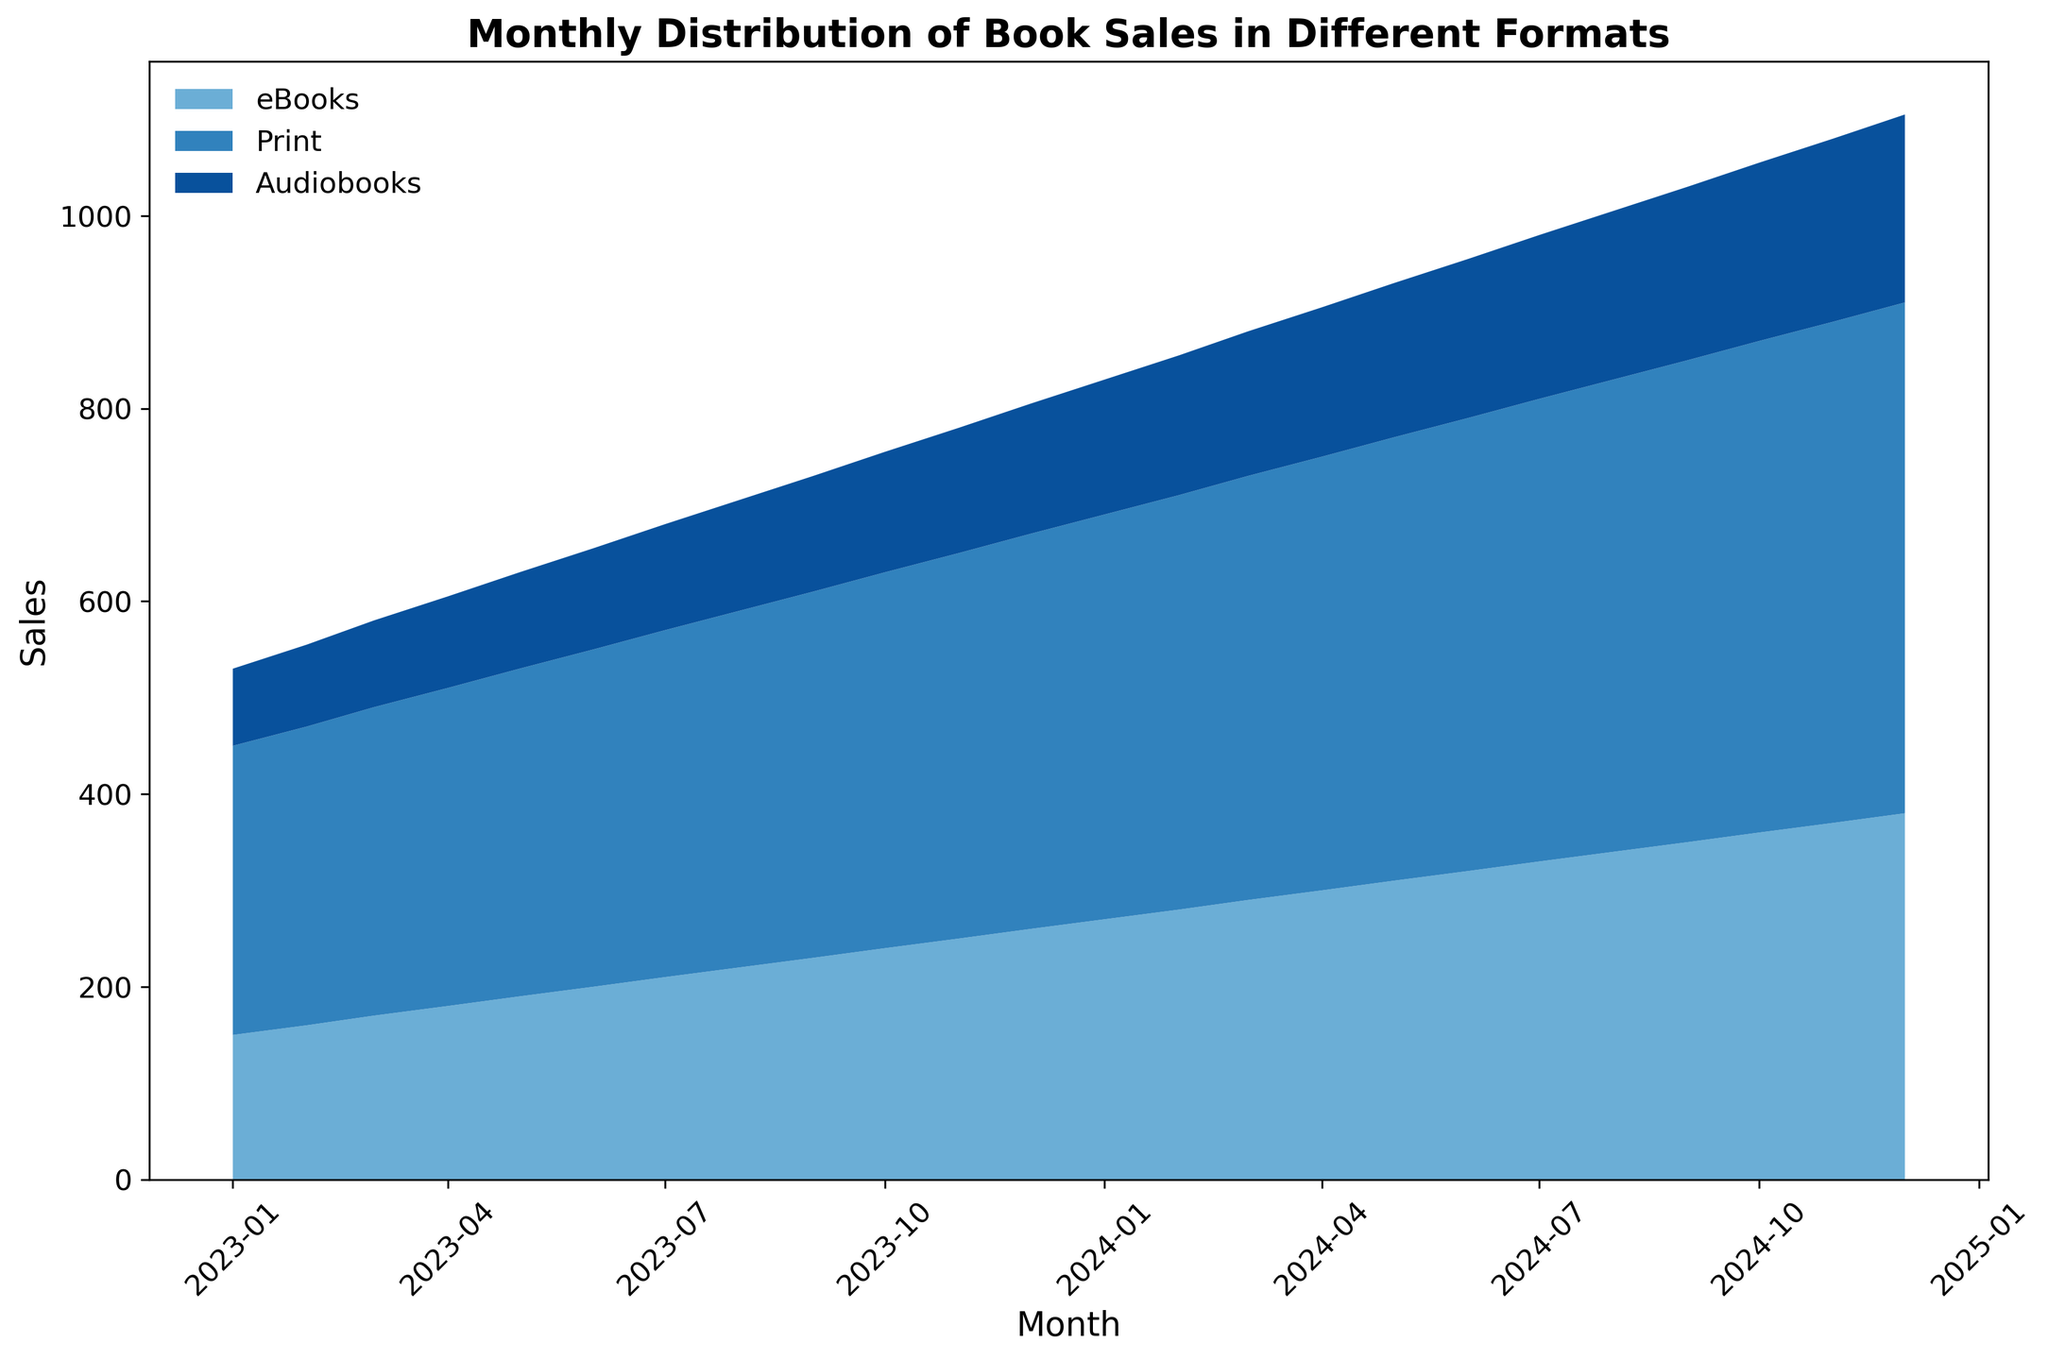Which format had the highest sales in January 2023? By looking at the chart, we can see the heights of the areas for each format in January. The printed books area is the tallest.
Answer: Print What is the total number of books sold across all formats in March 2024? We need to sum the values for eBooks, Print, and Audiobooks for March 2024. From the data: 290 (eBooks) + 440 (Print) + 150 (Audiobooks) = 880
Answer: 880 Which format shows the most significant increase in sales over the observed period? By comparing the increase in the areas of each format, we can see the increase from the smallest to the largest. eBooks rise from 150 to 380, Print from 300 to 530, and Audiobooks from 80 to 195. Print books show the largest increase.
Answer: Print What is the average monthly sales for Audiobooks in 2023? To find the average, sum all Audiobooks sales from 2023 and divide by the number of months (12). (80 + 85 + 90 + 95 + 100 + 105 + 110 + 115 + 120 + 125 + 130 + 135) / 12 = 110
Answer: 110 During which month did eBooks and Audiobooks have the same sales? By observing the chart, we look for the point where the areas for eBooks and Audiobooks overlap exactly at one value. This occurs in none of the months; their values are always different.
Answer: None Are the sales for Print books always higher than those for eBooks and Audiobooks? By observing the graph, we can see that the Print book area is always above the other two formats throughout the timeline.
Answer: Yes How have the total monthly sales changed from January 2023 to December 2024? We need to compare the total sales in January 2023 (150 + 300 + 80 = 530) with December 2024 (380 + 530 + 195 = 1105). Total sales have increased over this period.
Answer: Increased Which month had the highest combined sales for all formats? By looking at the chart and identifying the month with the highest point of the combined area for all formats, December 2024 shows the highest peak.
Answer: December 2024 Did Audiobooks sales consistently increase every month? By following the height of the Audiobooks area chart month by month, we can see it increases without any decrease.
Answer: Yes What is the difference in sales between eBooks and Print books in June 2024? Subtract the eBooks sales from the Print sales for June 2024: 470 (Print) – 320 (eBooks) = 150
Answer: 150 